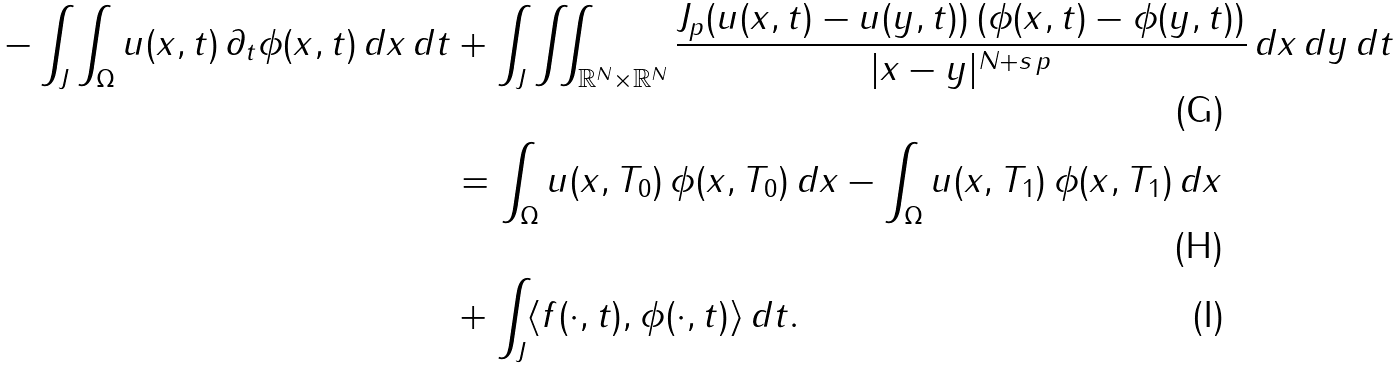Convert formula to latex. <formula><loc_0><loc_0><loc_500><loc_500>- \int _ { J } \int _ { \Omega } u ( x , t ) \, \partial _ { t } \phi ( x , t ) \, d x \, d t & + \int _ { J } \iint _ { \mathbb { R } ^ { N } \times \mathbb { R } ^ { N } } \frac { J _ { p } ( u ( x , t ) - u ( y , t ) ) \, ( \phi ( x , t ) - \phi ( y , t ) ) } { | x - y | ^ { N + s \, p } } \, d x \, d y \, d t \\ & = \int _ { \Omega } u ( x , T _ { 0 } ) \, \phi ( x , T _ { 0 } ) \, d x - \int _ { \Omega } u ( x , T _ { 1 } ) \, \phi ( x , T _ { 1 } ) \, d x \\ & + \int _ { J } \langle f ( \cdot , t ) , \phi ( \cdot , t ) \rangle \, d t .</formula> 